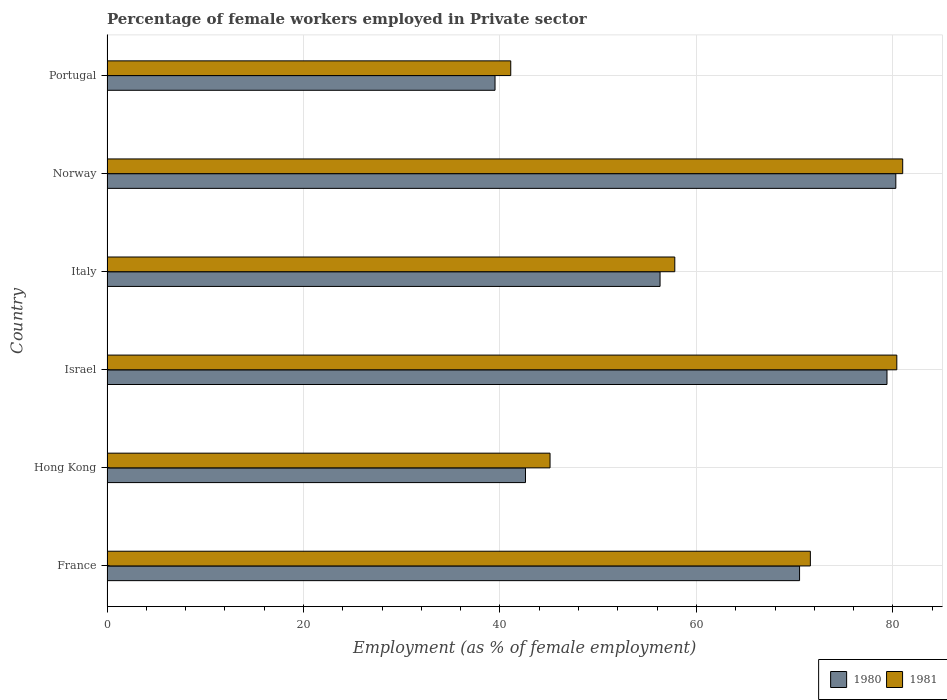How many different coloured bars are there?
Your answer should be very brief. 2. How many groups of bars are there?
Your answer should be very brief. 6. Are the number of bars per tick equal to the number of legend labels?
Offer a very short reply. Yes. What is the label of the 2nd group of bars from the top?
Ensure brevity in your answer.  Norway. What is the percentage of females employed in Private sector in 1980 in Israel?
Offer a very short reply. 79.4. Across all countries, what is the maximum percentage of females employed in Private sector in 1981?
Give a very brief answer. 81. Across all countries, what is the minimum percentage of females employed in Private sector in 1981?
Make the answer very short. 41.1. In which country was the percentage of females employed in Private sector in 1980 maximum?
Your answer should be very brief. Norway. In which country was the percentage of females employed in Private sector in 1981 minimum?
Your answer should be very brief. Portugal. What is the total percentage of females employed in Private sector in 1981 in the graph?
Your answer should be compact. 377. What is the difference between the percentage of females employed in Private sector in 1980 in Israel and that in Italy?
Keep it short and to the point. 23.1. What is the difference between the percentage of females employed in Private sector in 1981 in Hong Kong and the percentage of females employed in Private sector in 1980 in Portugal?
Your answer should be very brief. 5.6. What is the average percentage of females employed in Private sector in 1981 per country?
Provide a succinct answer. 62.83. What is the difference between the percentage of females employed in Private sector in 1980 and percentage of females employed in Private sector in 1981 in France?
Make the answer very short. -1.1. In how many countries, is the percentage of females employed in Private sector in 1980 greater than 32 %?
Your answer should be compact. 6. What is the ratio of the percentage of females employed in Private sector in 1981 in France to that in Portugal?
Your response must be concise. 1.74. Is the percentage of females employed in Private sector in 1980 in France less than that in Portugal?
Keep it short and to the point. No. Is the difference between the percentage of females employed in Private sector in 1980 in Israel and Norway greater than the difference between the percentage of females employed in Private sector in 1981 in Israel and Norway?
Your answer should be very brief. No. What is the difference between the highest and the second highest percentage of females employed in Private sector in 1980?
Keep it short and to the point. 0.9. What is the difference between the highest and the lowest percentage of females employed in Private sector in 1980?
Offer a terse response. 40.8. What does the 1st bar from the top in Portugal represents?
Offer a terse response. 1981. How many countries are there in the graph?
Provide a succinct answer. 6. Are the values on the major ticks of X-axis written in scientific E-notation?
Your answer should be very brief. No. Does the graph contain any zero values?
Keep it short and to the point. No. Where does the legend appear in the graph?
Offer a very short reply. Bottom right. How are the legend labels stacked?
Give a very brief answer. Horizontal. What is the title of the graph?
Keep it short and to the point. Percentage of female workers employed in Private sector. Does "1990" appear as one of the legend labels in the graph?
Ensure brevity in your answer.  No. What is the label or title of the X-axis?
Provide a short and direct response. Employment (as % of female employment). What is the Employment (as % of female employment) of 1980 in France?
Keep it short and to the point. 70.5. What is the Employment (as % of female employment) of 1981 in France?
Provide a succinct answer. 71.6. What is the Employment (as % of female employment) of 1980 in Hong Kong?
Offer a very short reply. 42.6. What is the Employment (as % of female employment) of 1981 in Hong Kong?
Your response must be concise. 45.1. What is the Employment (as % of female employment) of 1980 in Israel?
Keep it short and to the point. 79.4. What is the Employment (as % of female employment) in 1981 in Israel?
Provide a short and direct response. 80.4. What is the Employment (as % of female employment) in 1980 in Italy?
Provide a short and direct response. 56.3. What is the Employment (as % of female employment) of 1981 in Italy?
Your answer should be compact. 57.8. What is the Employment (as % of female employment) of 1980 in Norway?
Offer a terse response. 80.3. What is the Employment (as % of female employment) in 1981 in Norway?
Give a very brief answer. 81. What is the Employment (as % of female employment) of 1980 in Portugal?
Provide a succinct answer. 39.5. What is the Employment (as % of female employment) of 1981 in Portugal?
Ensure brevity in your answer.  41.1. Across all countries, what is the maximum Employment (as % of female employment) in 1980?
Provide a short and direct response. 80.3. Across all countries, what is the minimum Employment (as % of female employment) of 1980?
Offer a terse response. 39.5. Across all countries, what is the minimum Employment (as % of female employment) in 1981?
Your answer should be compact. 41.1. What is the total Employment (as % of female employment) in 1980 in the graph?
Give a very brief answer. 368.6. What is the total Employment (as % of female employment) in 1981 in the graph?
Provide a short and direct response. 377. What is the difference between the Employment (as % of female employment) of 1980 in France and that in Hong Kong?
Provide a short and direct response. 27.9. What is the difference between the Employment (as % of female employment) of 1981 in France and that in Hong Kong?
Your answer should be compact. 26.5. What is the difference between the Employment (as % of female employment) of 1980 in France and that in Italy?
Give a very brief answer. 14.2. What is the difference between the Employment (as % of female employment) in 1981 in France and that in Italy?
Give a very brief answer. 13.8. What is the difference between the Employment (as % of female employment) of 1980 in France and that in Norway?
Your answer should be very brief. -9.8. What is the difference between the Employment (as % of female employment) of 1980 in France and that in Portugal?
Make the answer very short. 31. What is the difference between the Employment (as % of female employment) in 1981 in France and that in Portugal?
Your answer should be very brief. 30.5. What is the difference between the Employment (as % of female employment) of 1980 in Hong Kong and that in Israel?
Offer a very short reply. -36.8. What is the difference between the Employment (as % of female employment) in 1981 in Hong Kong and that in Israel?
Provide a short and direct response. -35.3. What is the difference between the Employment (as % of female employment) of 1980 in Hong Kong and that in Italy?
Offer a terse response. -13.7. What is the difference between the Employment (as % of female employment) of 1981 in Hong Kong and that in Italy?
Offer a very short reply. -12.7. What is the difference between the Employment (as % of female employment) of 1980 in Hong Kong and that in Norway?
Keep it short and to the point. -37.7. What is the difference between the Employment (as % of female employment) of 1981 in Hong Kong and that in Norway?
Keep it short and to the point. -35.9. What is the difference between the Employment (as % of female employment) of 1980 in Hong Kong and that in Portugal?
Offer a terse response. 3.1. What is the difference between the Employment (as % of female employment) of 1980 in Israel and that in Italy?
Your answer should be very brief. 23.1. What is the difference between the Employment (as % of female employment) in 1981 in Israel and that in Italy?
Offer a terse response. 22.6. What is the difference between the Employment (as % of female employment) in 1981 in Israel and that in Norway?
Your answer should be compact. -0.6. What is the difference between the Employment (as % of female employment) in 1980 in Israel and that in Portugal?
Your answer should be very brief. 39.9. What is the difference between the Employment (as % of female employment) in 1981 in Israel and that in Portugal?
Your answer should be very brief. 39.3. What is the difference between the Employment (as % of female employment) in 1981 in Italy and that in Norway?
Make the answer very short. -23.2. What is the difference between the Employment (as % of female employment) in 1980 in Italy and that in Portugal?
Your response must be concise. 16.8. What is the difference between the Employment (as % of female employment) in 1980 in Norway and that in Portugal?
Offer a terse response. 40.8. What is the difference between the Employment (as % of female employment) of 1981 in Norway and that in Portugal?
Provide a short and direct response. 39.9. What is the difference between the Employment (as % of female employment) in 1980 in France and the Employment (as % of female employment) in 1981 in Hong Kong?
Provide a short and direct response. 25.4. What is the difference between the Employment (as % of female employment) in 1980 in France and the Employment (as % of female employment) in 1981 in Norway?
Offer a very short reply. -10.5. What is the difference between the Employment (as % of female employment) of 1980 in France and the Employment (as % of female employment) of 1981 in Portugal?
Make the answer very short. 29.4. What is the difference between the Employment (as % of female employment) of 1980 in Hong Kong and the Employment (as % of female employment) of 1981 in Israel?
Offer a terse response. -37.8. What is the difference between the Employment (as % of female employment) in 1980 in Hong Kong and the Employment (as % of female employment) in 1981 in Italy?
Your response must be concise. -15.2. What is the difference between the Employment (as % of female employment) in 1980 in Hong Kong and the Employment (as % of female employment) in 1981 in Norway?
Offer a very short reply. -38.4. What is the difference between the Employment (as % of female employment) in 1980 in Hong Kong and the Employment (as % of female employment) in 1981 in Portugal?
Offer a terse response. 1.5. What is the difference between the Employment (as % of female employment) in 1980 in Israel and the Employment (as % of female employment) in 1981 in Italy?
Offer a terse response. 21.6. What is the difference between the Employment (as % of female employment) in 1980 in Israel and the Employment (as % of female employment) in 1981 in Portugal?
Provide a succinct answer. 38.3. What is the difference between the Employment (as % of female employment) in 1980 in Italy and the Employment (as % of female employment) in 1981 in Norway?
Your answer should be very brief. -24.7. What is the difference between the Employment (as % of female employment) in 1980 in Norway and the Employment (as % of female employment) in 1981 in Portugal?
Your answer should be very brief. 39.2. What is the average Employment (as % of female employment) in 1980 per country?
Make the answer very short. 61.43. What is the average Employment (as % of female employment) in 1981 per country?
Provide a short and direct response. 62.83. What is the difference between the Employment (as % of female employment) of 1980 and Employment (as % of female employment) of 1981 in Hong Kong?
Offer a terse response. -2.5. What is the difference between the Employment (as % of female employment) of 1980 and Employment (as % of female employment) of 1981 in Israel?
Provide a succinct answer. -1. What is the difference between the Employment (as % of female employment) of 1980 and Employment (as % of female employment) of 1981 in Italy?
Provide a short and direct response. -1.5. What is the difference between the Employment (as % of female employment) in 1980 and Employment (as % of female employment) in 1981 in Portugal?
Your answer should be very brief. -1.6. What is the ratio of the Employment (as % of female employment) of 1980 in France to that in Hong Kong?
Provide a short and direct response. 1.65. What is the ratio of the Employment (as % of female employment) in 1981 in France to that in Hong Kong?
Ensure brevity in your answer.  1.59. What is the ratio of the Employment (as % of female employment) in 1980 in France to that in Israel?
Your answer should be very brief. 0.89. What is the ratio of the Employment (as % of female employment) of 1981 in France to that in Israel?
Offer a terse response. 0.89. What is the ratio of the Employment (as % of female employment) in 1980 in France to that in Italy?
Your answer should be compact. 1.25. What is the ratio of the Employment (as % of female employment) in 1981 in France to that in Italy?
Offer a very short reply. 1.24. What is the ratio of the Employment (as % of female employment) of 1980 in France to that in Norway?
Your answer should be compact. 0.88. What is the ratio of the Employment (as % of female employment) of 1981 in France to that in Norway?
Give a very brief answer. 0.88. What is the ratio of the Employment (as % of female employment) in 1980 in France to that in Portugal?
Your response must be concise. 1.78. What is the ratio of the Employment (as % of female employment) in 1981 in France to that in Portugal?
Ensure brevity in your answer.  1.74. What is the ratio of the Employment (as % of female employment) in 1980 in Hong Kong to that in Israel?
Offer a very short reply. 0.54. What is the ratio of the Employment (as % of female employment) of 1981 in Hong Kong to that in Israel?
Make the answer very short. 0.56. What is the ratio of the Employment (as % of female employment) in 1980 in Hong Kong to that in Italy?
Provide a short and direct response. 0.76. What is the ratio of the Employment (as % of female employment) of 1981 in Hong Kong to that in Italy?
Your answer should be compact. 0.78. What is the ratio of the Employment (as % of female employment) in 1980 in Hong Kong to that in Norway?
Offer a very short reply. 0.53. What is the ratio of the Employment (as % of female employment) in 1981 in Hong Kong to that in Norway?
Give a very brief answer. 0.56. What is the ratio of the Employment (as % of female employment) of 1980 in Hong Kong to that in Portugal?
Provide a short and direct response. 1.08. What is the ratio of the Employment (as % of female employment) in 1981 in Hong Kong to that in Portugal?
Offer a very short reply. 1.1. What is the ratio of the Employment (as % of female employment) of 1980 in Israel to that in Italy?
Your answer should be compact. 1.41. What is the ratio of the Employment (as % of female employment) in 1981 in Israel to that in Italy?
Offer a terse response. 1.39. What is the ratio of the Employment (as % of female employment) of 1980 in Israel to that in Norway?
Offer a terse response. 0.99. What is the ratio of the Employment (as % of female employment) of 1980 in Israel to that in Portugal?
Offer a terse response. 2.01. What is the ratio of the Employment (as % of female employment) in 1981 in Israel to that in Portugal?
Offer a very short reply. 1.96. What is the ratio of the Employment (as % of female employment) of 1980 in Italy to that in Norway?
Offer a very short reply. 0.7. What is the ratio of the Employment (as % of female employment) in 1981 in Italy to that in Norway?
Your response must be concise. 0.71. What is the ratio of the Employment (as % of female employment) of 1980 in Italy to that in Portugal?
Provide a short and direct response. 1.43. What is the ratio of the Employment (as % of female employment) of 1981 in Italy to that in Portugal?
Your answer should be compact. 1.41. What is the ratio of the Employment (as % of female employment) in 1980 in Norway to that in Portugal?
Give a very brief answer. 2.03. What is the ratio of the Employment (as % of female employment) in 1981 in Norway to that in Portugal?
Your response must be concise. 1.97. What is the difference between the highest and the second highest Employment (as % of female employment) in 1980?
Offer a very short reply. 0.9. What is the difference between the highest and the lowest Employment (as % of female employment) of 1980?
Provide a short and direct response. 40.8. What is the difference between the highest and the lowest Employment (as % of female employment) in 1981?
Provide a short and direct response. 39.9. 